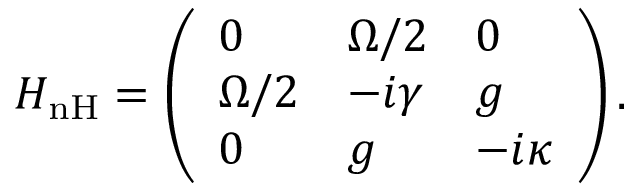<formula> <loc_0><loc_0><loc_500><loc_500>H _ { n H } = \left ( \begin{array} { l l l } { 0 } & { \Omega / 2 } & { 0 } \\ { \Omega / 2 } & { - i \gamma } & { g } \\ { 0 } & { g } & { - i \kappa } \end{array} \right ) .</formula> 